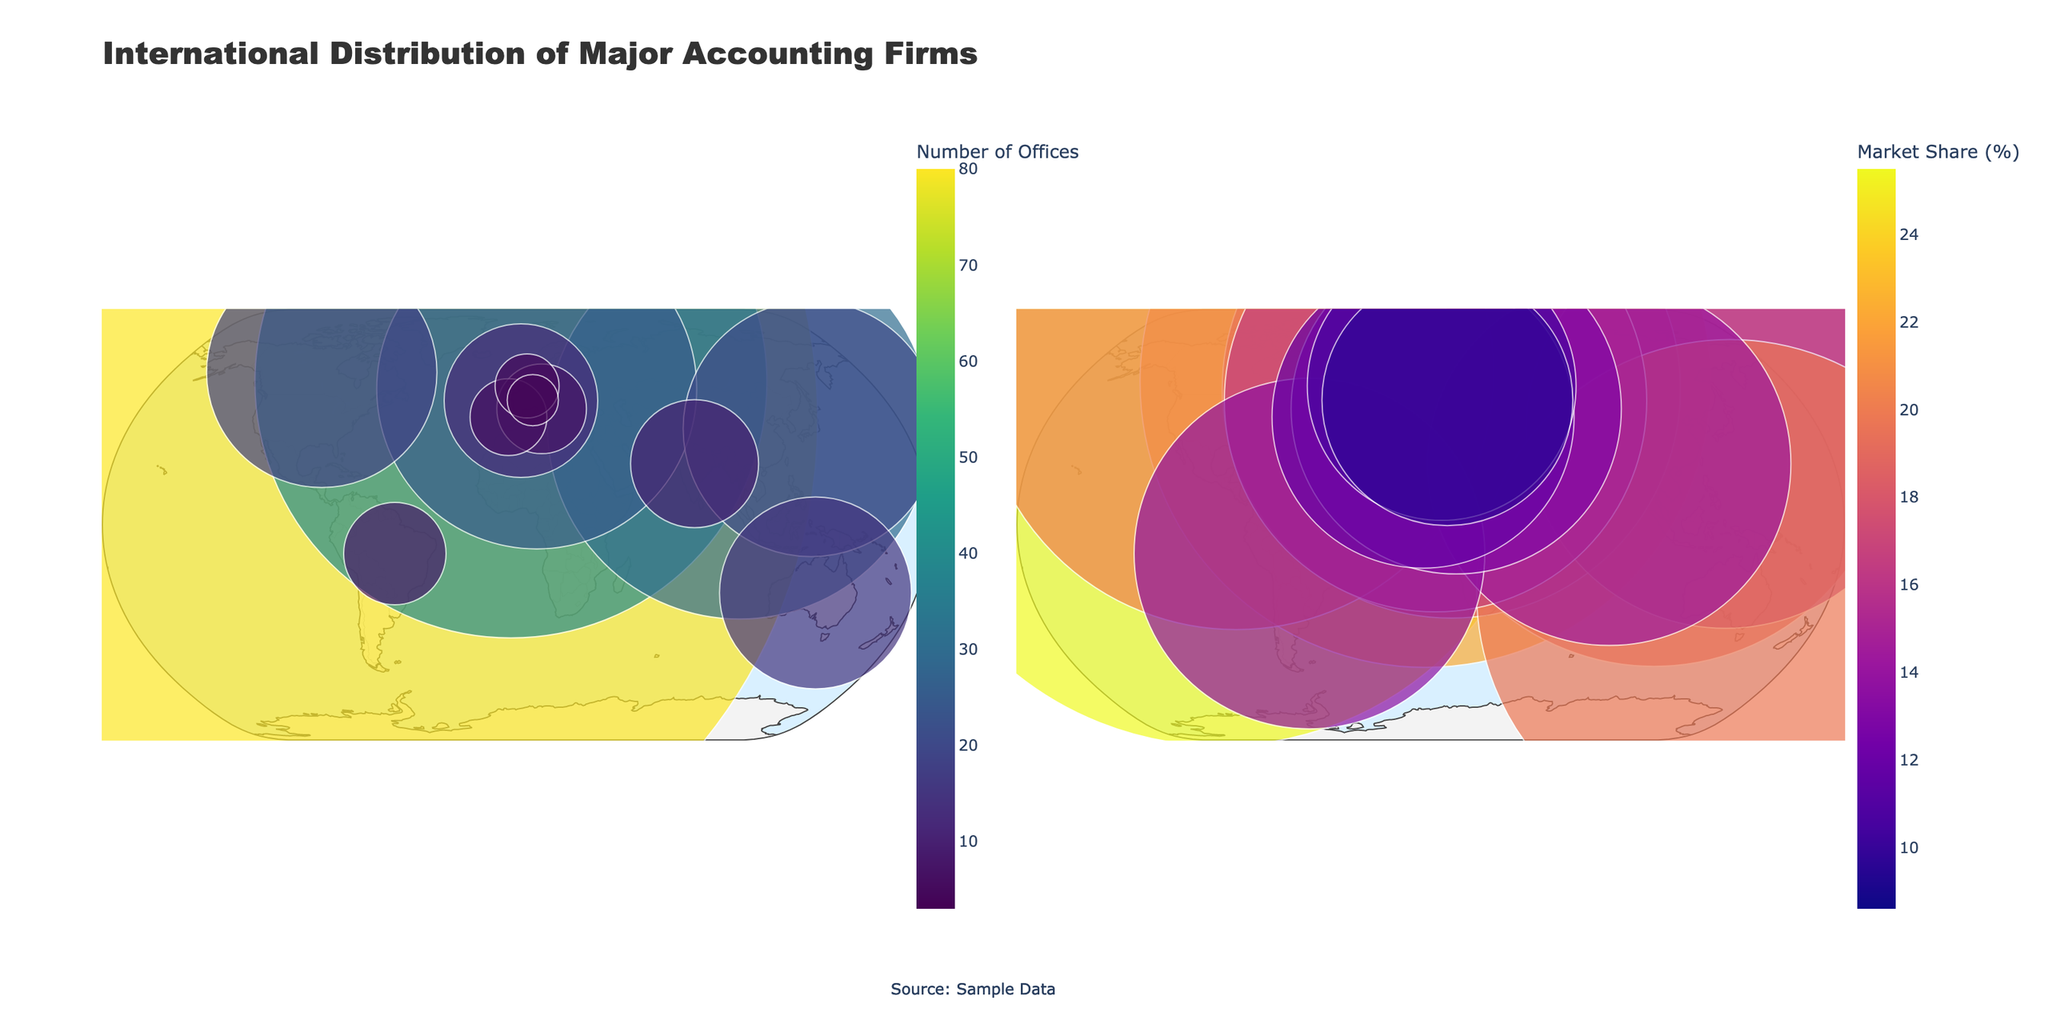What's the title of the figure? The title of the figure is displayed at the top of the plot. It clearly states the content being visualized.
Answer: International Distribution of Major Accounting Firms How many countries are displayed in the figure? By counting the unique country names listed, we can determine the number of countries shown in the plot.
Answer: 15 Which country has the largest number of Deloitte offices? By looking at the "Number of Offices by Country" subplot and identifying the largest marker size/color associated with Deloitte, we see that the largest number is in the United States.
Answer: United States What is the market share of PwC in the United Kingdom? The "Market Share by Country" subplot can be referenced to find the text label for the United Kingdom, which indicates PwC's market share as 22.3%.
Answer: 22.3% Which firm has the smallest number of offices in a single country and what is that number? By observing the smallest markers in the "Number of Offices by Country" subplot, we see that Singapore has the smallest number, which is for EY with 3 offices.
Answer: EY, 3 offices Calculate the average market share of Deloitte across all the countries it operates in. Identify the countries where Deloitte operates: United States, Japan, India, and Netherlands. Add their market shares: 25.5 + 15.6 + 14.2 + 10.5 = 65.8. Divide by the number of countries (4).
Answer: 16.45 Which country has the lowest market share percentage and what is that percentage? By observing the "Market Share by Country" subplot, we see that Singapore has the smallest marker for the market share, which is 8.6%.
Answer: Singapore, 8.6% Compare the number of offices of KPMG in Germany and France. Which country has more and by how many? KPMG's numbers are shown in the "Number of Offices by Country" subplot. Germany has 25 offices and France has 12, so Germany has more by 13 offices.
Answer: Germany, 13 offices Which firm has the highest total number of offices across all countries? Sum the number of offices for each firm and compare:
Deloitte: 80 + 20 + 10 + 5 = 115
PwC: 40 + 18 + 8 + 4 = 70
EY: 30 + 15 + 7 + 3 = 55
KPMG: 25 + 12 + 6 = 43
Deloitte has the highest total.
Answer: Deloitte 